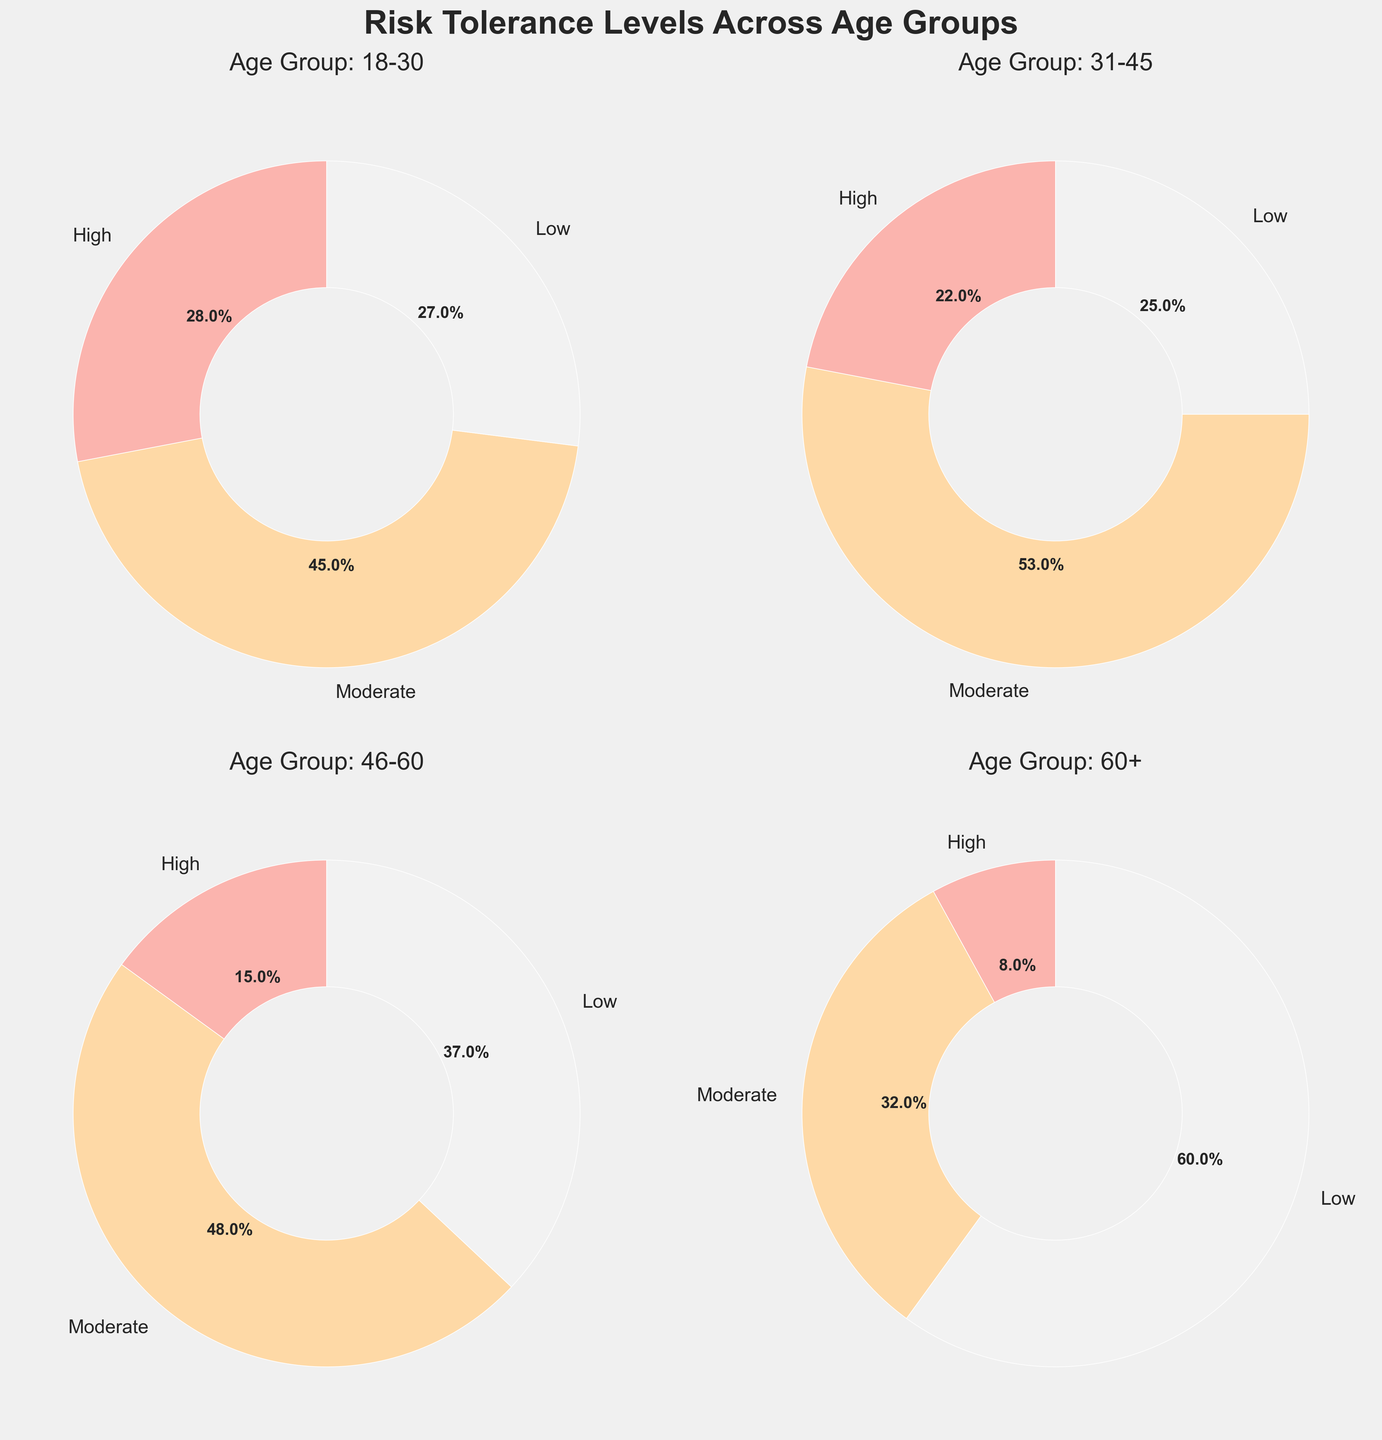What is the percentage difference in low-risk tolerance between the age groups 18-30 and 60+? The percentage of low-risk tolerance in the age group 18-30 is 27%, and in the age group 60+ is 60%. The difference is found by subtracting the smaller percentage from the larger one: 60% - 27% = 33%.
Answer: 33% Which age group has the highest percentage of high-risk tolerance and what is that percentage? The pie charts indicate the "High" risk tolerance percentages for each age group. Age group 18-30 has the highest with 28%.
Answer: Age group 18-30, 28% What is the combined percentage of moderate-risk tolerance for the age groups 31-45 and 46-60? We take the moderate-risk tolerance percentages for each group: 53% for 31-45, and 48% for 46-60. Adding these together gives us 53% + 48% = 101%.
Answer: 101% In which age group is low-risk tolerance the most prevalent, and what percentage of investors does it cover? By looking at the percentages in the 'Low' category for each group, it is evident that the age group 60+ has the highest percentage with 60%.
Answer: Age group 60+, 60% Comparing the age group 31-45, is the percentage of moderate-risk tolerance higher or lower than the combined percentage of high and low-risk tolerance for the same group? The moderate-risk tolerance for 31-45 is 53%. The sum of high (22%) and low (25%) is 22% + 25% = 47%. Since 53% > 47%, the moderate-risk tolerance is higher.
Answer: Higher Which risk tolerance level is least prevalent in the age group 46-60, and what is the percentage? For the age group 46-60, the percentages are 15% for high, 48% for moderate, and 37% for low. The least prevalent is high with 15%.
Answer: High, 15% What is the sum of high-risk tolerance percentages across all age groups? Add together the high-risk tolerance percentages for each age group: 28% (18-30), 22% (31-45), 15% (46-60), and 8% (60+). This gives 28% + 22% + 15% + 8% = 73%.
Answer: 73% Which age group has the smallest difference between its highest and lowest risk tolerance levels, and what is the difference? For the age groups, calculate the difference between the highest and lowest percentages: 18-30: 45% - 27% = 18%, 31-45: 53% - 22% = 31%, 46-60: 48% - 15% = 33%, 60+: 60% - 8% = 52%. The smallest difference is for 18-30, with an 18% difference.
Answer: Age group 18-30, 18% 